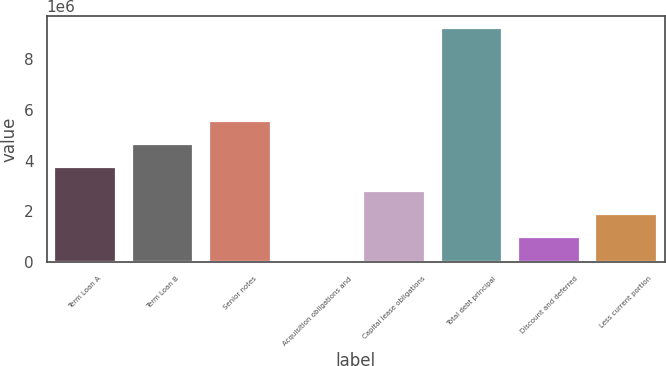<chart> <loc_0><loc_0><loc_500><loc_500><bar_chart><fcel>Term Loan A<fcel>Term Loan B<fcel>Senior notes<fcel>Acquisition obligations and<fcel>Capital lease obligations<fcel>Total debt principal<fcel>Discount and deferred<fcel>Less current portion<nl><fcel>3.73292e+06<fcel>4.64849e+06<fcel>5.56406e+06<fcel>70645<fcel>2.81735e+06<fcel>9.22633e+06<fcel>986214<fcel>1.90178e+06<nl></chart> 